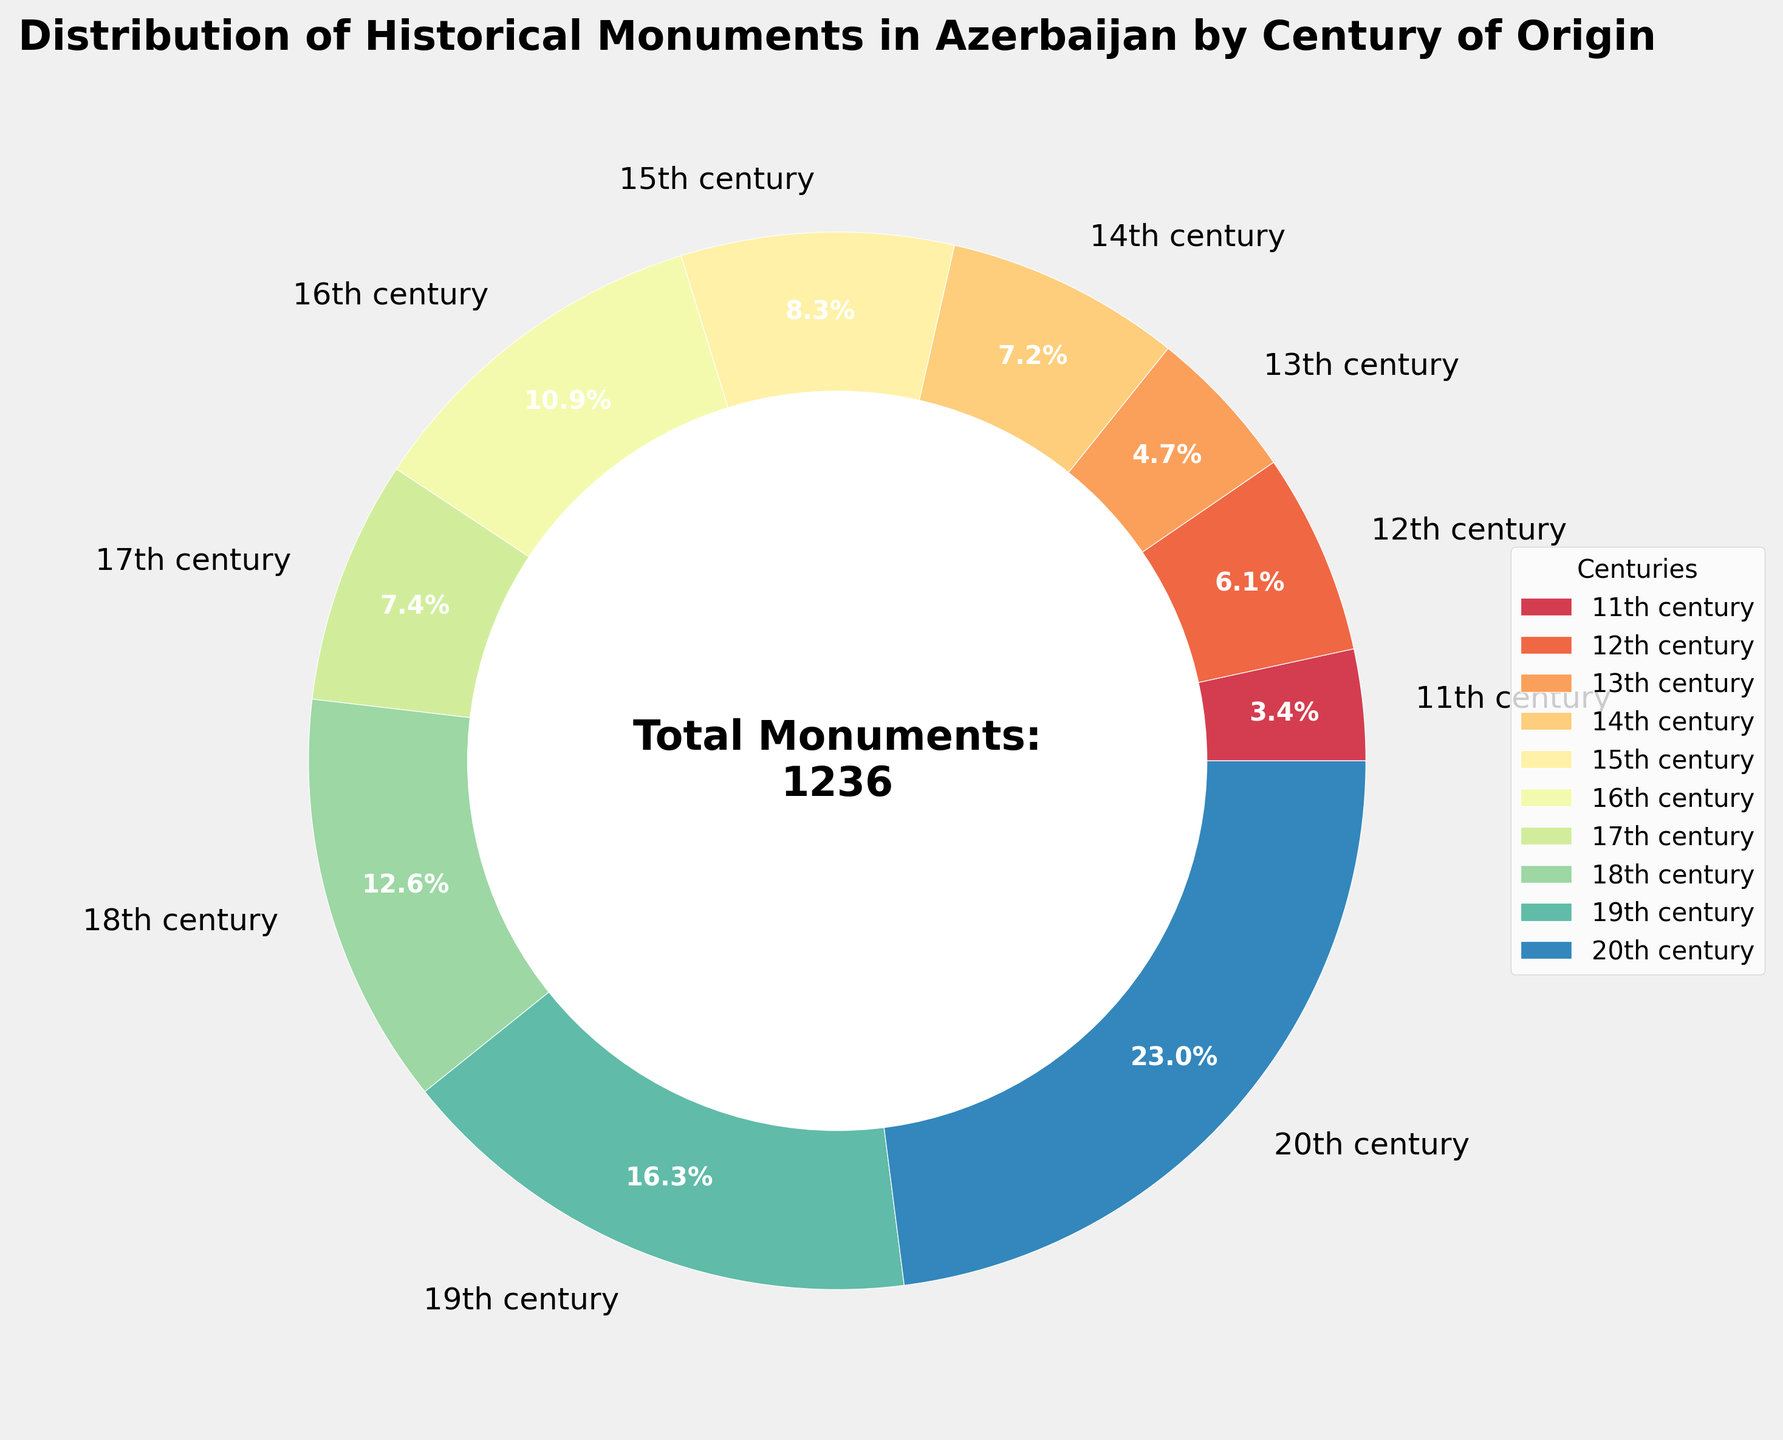What century has the highest number of historical monuments? By looking at the pie chart, you can see that the 20th century's segment is the largest. The label indicates 284 monuments.
Answer: 20th century What is the total percentage of monuments from the 18th and 19th centuries combined? The pie chart segments for the 18th and 19th centuries are 12.6% and 16.3%, respectively. Adding these gives 12.6% + 16.3% = 28.9%.
Answer: 28.9% Which century has fewer monuments: the 17th or the 14th? By comparing the segments, the 14th century has 89 monuments, while the 17th century has 92 monuments. The 14th century has fewer.
Answer: 14th century How many additional monuments are there in the 19th century compared to the 11th century? The pie chart shows 201 monuments in the 19th century and 42 in the 11th century. The difference is 201 - 42 = 159.
Answer: 159 Are there more monuments from the 15th century or the 16th century? The 15th century has 103 monuments, while the 16th century shows 135 monuments. Thus, the 16th century has more monuments.
Answer: 16th century What percentage of the total monuments come from the 11th, 12th, and 13th centuries combined? Adding the segments for the 11th (3.4%), 12th (6.1%), and 13th (4.7%) centuries gives 3.4% + 6.1% + 4.7% = 14.2%.
Answer: 14.2% What is the average number of monuments per century? The total number of monuments is 1236, and there are 10 centuries. The average is 1236 / 10 = 123.6.
Answer: 123.6 Compare the number of monuments in the 16th and 17th centuries to the combined total of those from the 11th and 12th centuries. Which group has more? The 16th and 17th centuries together have 135 + 92 = 227 monuments. The 11th and 12th centuries together have 42 + 76 = 118 monuments. 227 is greater than 118.
Answer: 16th and 17th centuries What's the ratio of the number of monuments in the 20th century to the number in the 18th century? The pie chart indicates 284 monuments in the 20th century and 156 in the 18th century. The ratio is 284:156, which simplifies to approximately 1.82:1.
Answer: 1.82:1 